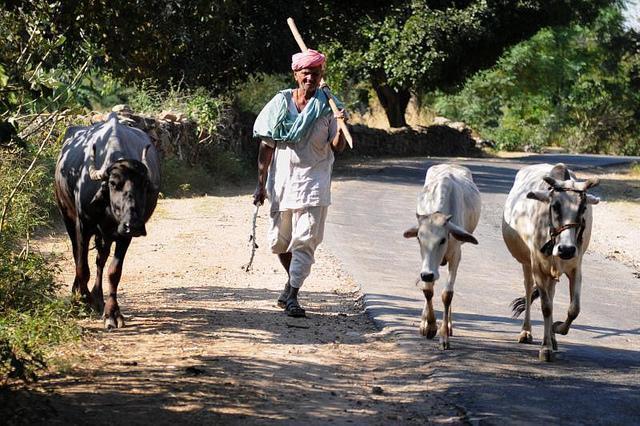What color is the turban worn by the man herding the cows?
Choose the correct response, then elucidate: 'Answer: answer
Rationale: rationale.'
Options: Red, blue, tan, white. Answer: red.
Rationale: The turban is red colored. How many cows are following around the man in the red turban?
Select the accurate answer and provide explanation: 'Answer: answer
Rationale: rationale.'
Options: Three, two, five, four. Answer: three.
Rationale: Two are on one side and one is on the other 